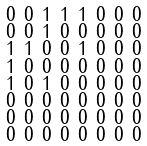<formula> <loc_0><loc_0><loc_500><loc_500>\begin{smallmatrix} 0 & 0 & 1 & 1 & 1 & 0 & 0 & 0 \\ 0 & 0 & 1 & 0 & 0 & 0 & 0 & 0 \\ 1 & 1 & 0 & 0 & 1 & 0 & 0 & 0 \\ 1 & 0 & 0 & 0 & 0 & 0 & 0 & 0 \\ 1 & 0 & 1 & 0 & 0 & 0 & 0 & 0 \\ 0 & 0 & 0 & 0 & 0 & 0 & 0 & 0 \\ 0 & 0 & 0 & 0 & 0 & 0 & 0 & 0 \\ 0 & 0 & 0 & 0 & 0 & 0 & 0 & 0 \end{smallmatrix}</formula> 